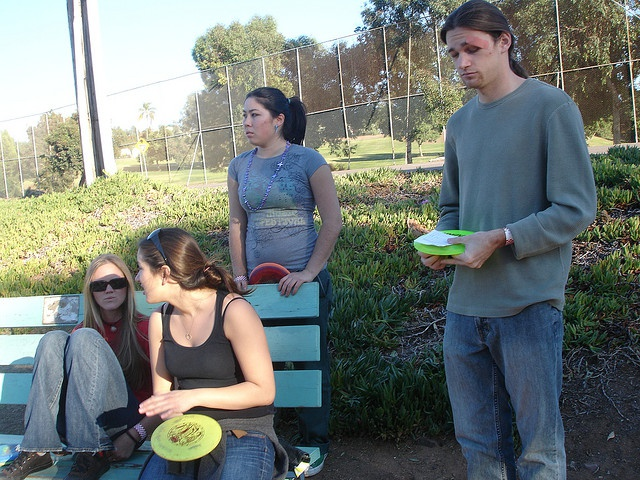Describe the objects in this image and their specific colors. I can see people in lightblue, blue, black, and gray tones, people in lightblue, black, tan, and gray tones, people in lightblue, black, gray, and darkgray tones, people in lightblue, gray, darkgray, and black tones, and bench in lightblue, teal, ivory, gray, and black tones in this image. 